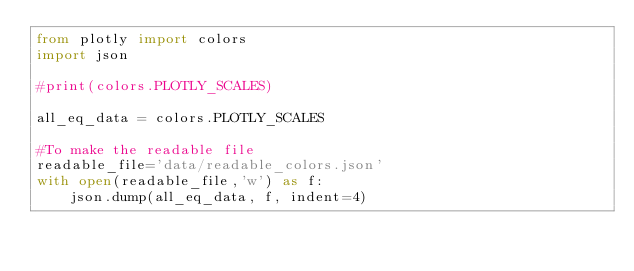<code> <loc_0><loc_0><loc_500><loc_500><_Python_>from plotly import colors
import json

#print(colors.PLOTLY_SCALES)

all_eq_data = colors.PLOTLY_SCALES

#To make the readable file
readable_file='data/readable_colors.json'
with open(readable_file,'w') as f:
	json.dump(all_eq_data, f, indent=4)</code> 